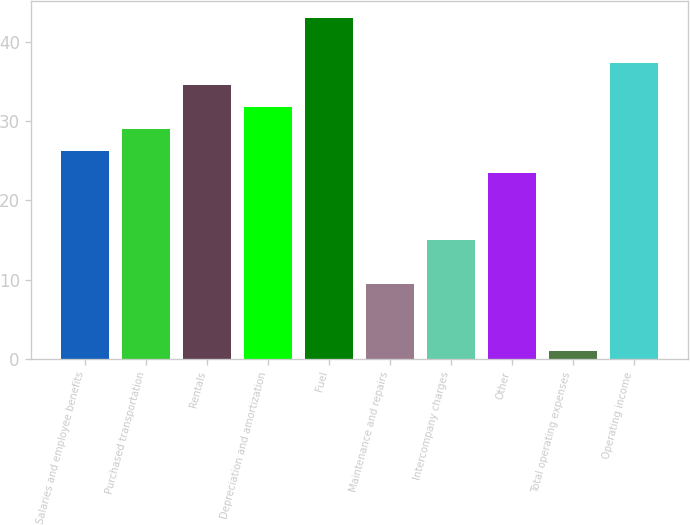Convert chart to OTSL. <chart><loc_0><loc_0><loc_500><loc_500><bar_chart><fcel>Salaries and employee benefits<fcel>Purchased transportation<fcel>Rentals<fcel>Depreciation and amortization<fcel>Fuel<fcel>Maintenance and repairs<fcel>Intercompany charges<fcel>Other<fcel>Total operating expenses<fcel>Operating income<nl><fcel>26.2<fcel>29<fcel>34.6<fcel>31.8<fcel>43<fcel>9.4<fcel>15<fcel>23.4<fcel>1<fcel>37.4<nl></chart> 